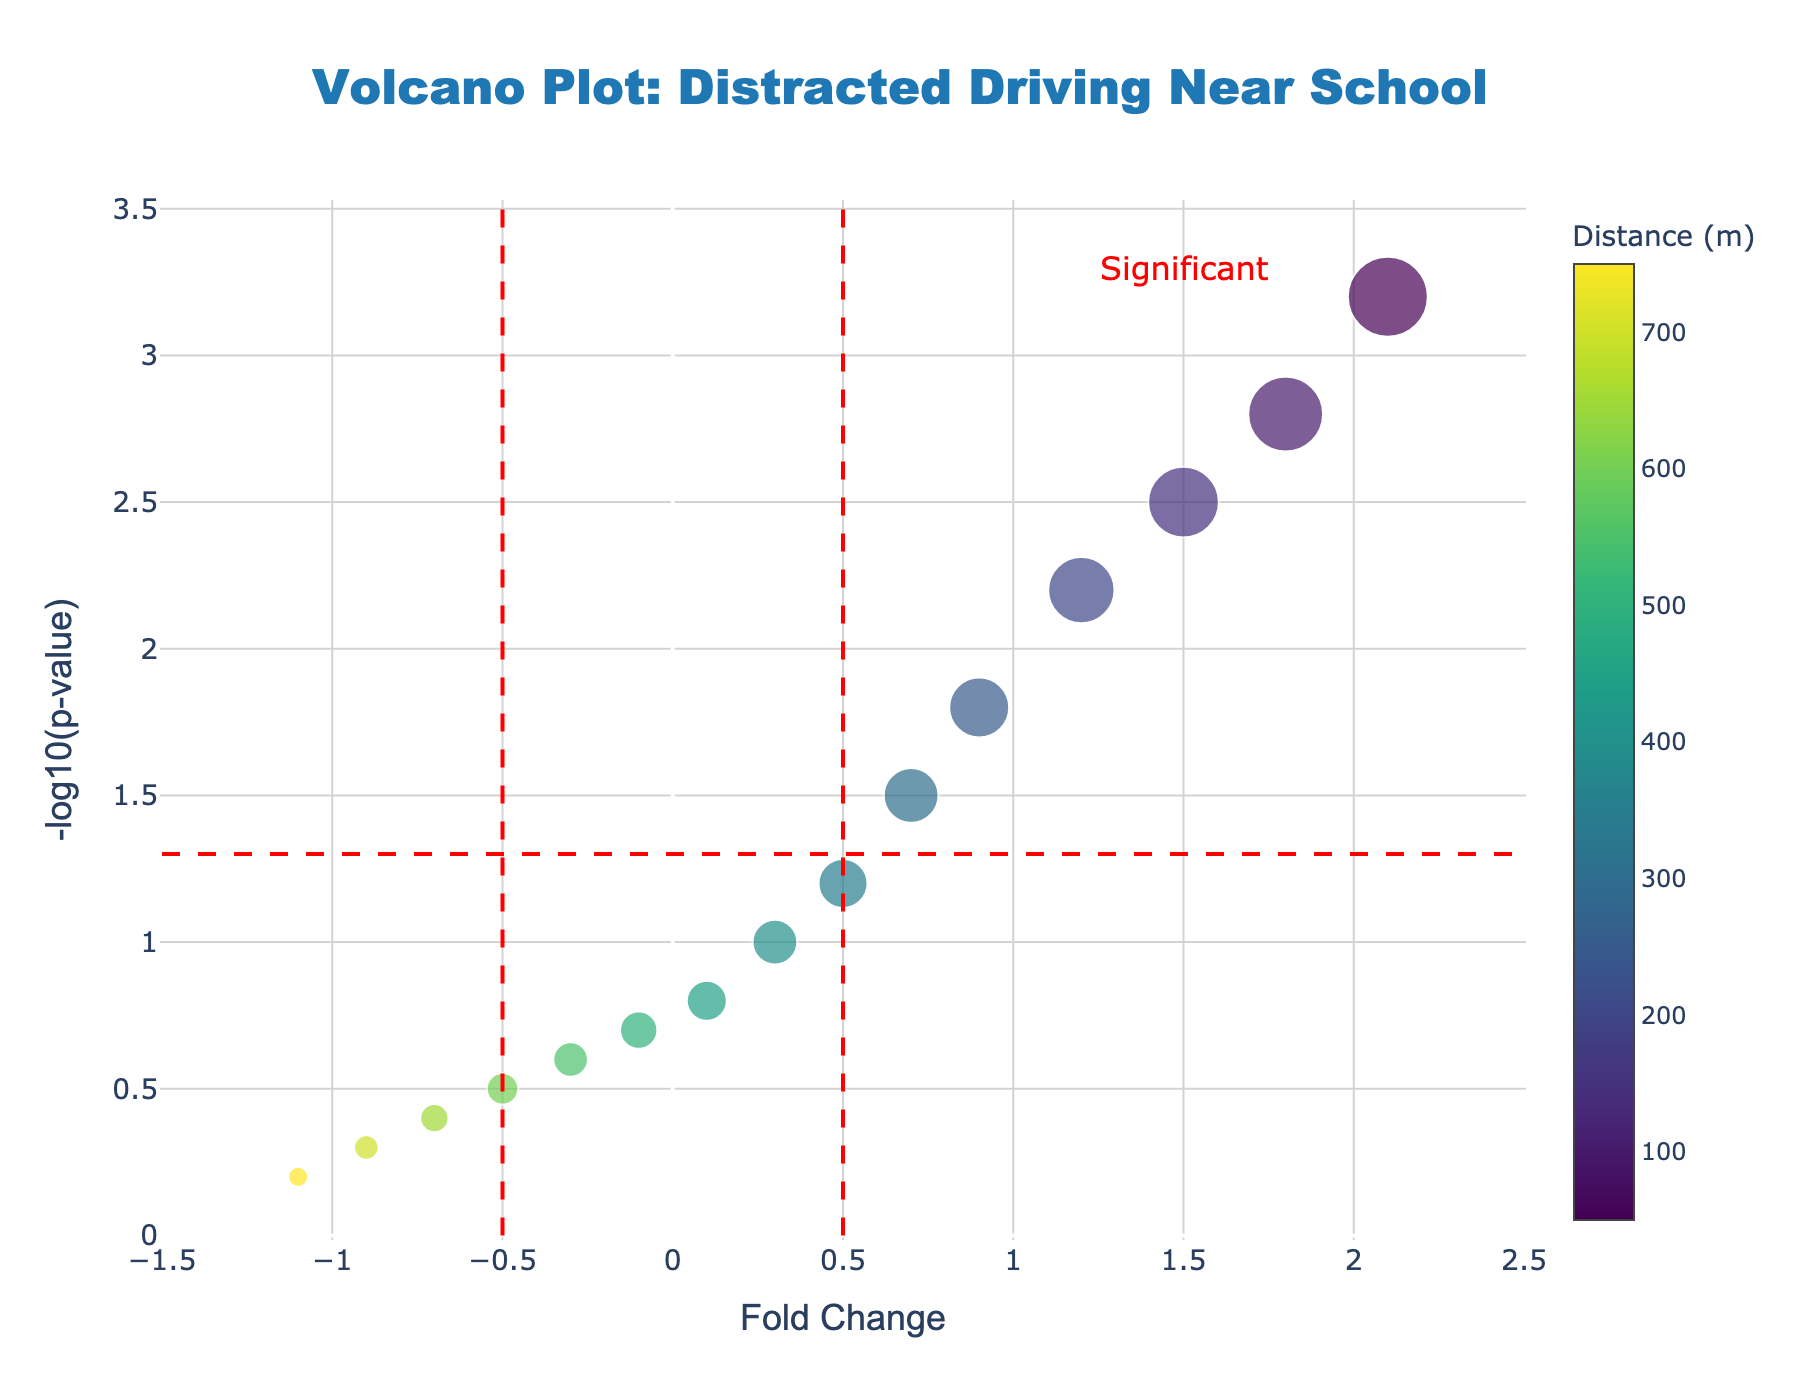What's the title of the plot? The title is typically located at the top of the plot and is clearly marked.
Answer: Volcano Plot: Distracted Driving Near School How many distinct distances are represented in the plot? By counting the different distance values shown on the colorbar, one can see there are distances ranging from 50 meters to 750 meters in steps of 50 meters.
Answer: 15 Which data point represents the highest number of occurrences and what is the distance associated with it? The size of the marker represents occurrences; the largest marker appears at a distance of 50 meters.
Answer: 50 meters What is the fold change and -log10(p-value) at 200 meters distance? By identifying the marker color corresponding to 200 meters and referencing the coordinates for that marker, we get x (Fold Change) = 1.2 and y (-log10(p-value)) = 2.2.
Answer: 1.2, 2.2 Which data points are considered significant based on the significance lines? Markers with y values (higher than 1.3 for -log10(p-value)) and x values (outside ±0.5 for Fold Change) fall within the significant region. These occur at distances of 50 to 200 meters.
Answer: 50, 100, 150, 200 meters Is there any data point with a negative fold change value? Negative fold changes lie to the left of 0 on the x-axis. From the plot, points at distances 500 to 750 meters have fold changes below zero.
Answer: Yes Which distance shows the minimum occurrences and what are its corresponding fold change and -log10(p-value)? The smallest marker, indicating the fewest occurrences, appears at a distance of 750 meters. Its coordinates are x (Fold Change) = -1.1 and y (-log10(p-value)) = 0.2.
Answer: 750 meters, -1.1, 0.2 What can you infer about distracted driving occurrences as the distance from the school increases? By observing the plot, the markers decrease in size, indicating fewer occurrences and lower significance, as distance from the school increases.
Answer: Occurrences and significance decrease with distance What is the trend of -log10(p-value) as distance from the school increases? As seen on the y-axis, the values generally decrease, indicating that the statistical significance of distracted driving occurrences decreases as distance increases.
Answer: Decreases Which range of distances highlight significant distracted driving occurrences? Significant points are those where the markers fall within the indicated "Significant" region, which is from 50 meters to 200 meters.
Answer: 50 to 200 meters 